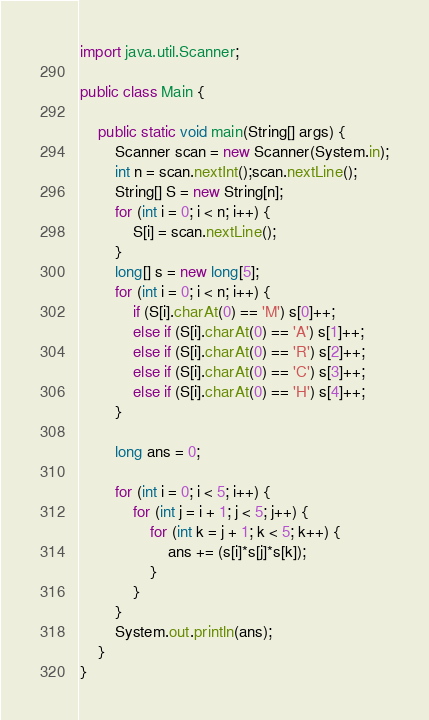Convert code to text. <code><loc_0><loc_0><loc_500><loc_500><_Java_>import java.util.Scanner;

public class Main {

	public static void main(String[] args) {
		Scanner scan = new Scanner(System.in);
		int n = scan.nextInt();scan.nextLine();
		String[] S = new String[n];
		for (int i = 0; i < n; i++) {
			S[i] = scan.nextLine();
		}
		long[] s = new long[5];
		for (int i = 0; i < n; i++) {
			if (S[i].charAt(0) == 'M') s[0]++;
			else if (S[i].charAt(0) == 'A') s[1]++;
			else if (S[i].charAt(0) == 'R') s[2]++;
			else if (S[i].charAt(0) == 'C') s[3]++;
			else if (S[i].charAt(0) == 'H') s[4]++;
		}

		long ans = 0;

		for (int i = 0; i < 5; i++) {
			for (int j = i + 1; j < 5; j++) {
				for (int k = j + 1; k < 5; k++) {
					ans += (s[i]*s[j]*s[k]);
				}
			}
		}
		System.out.println(ans);
	}
}
</code> 